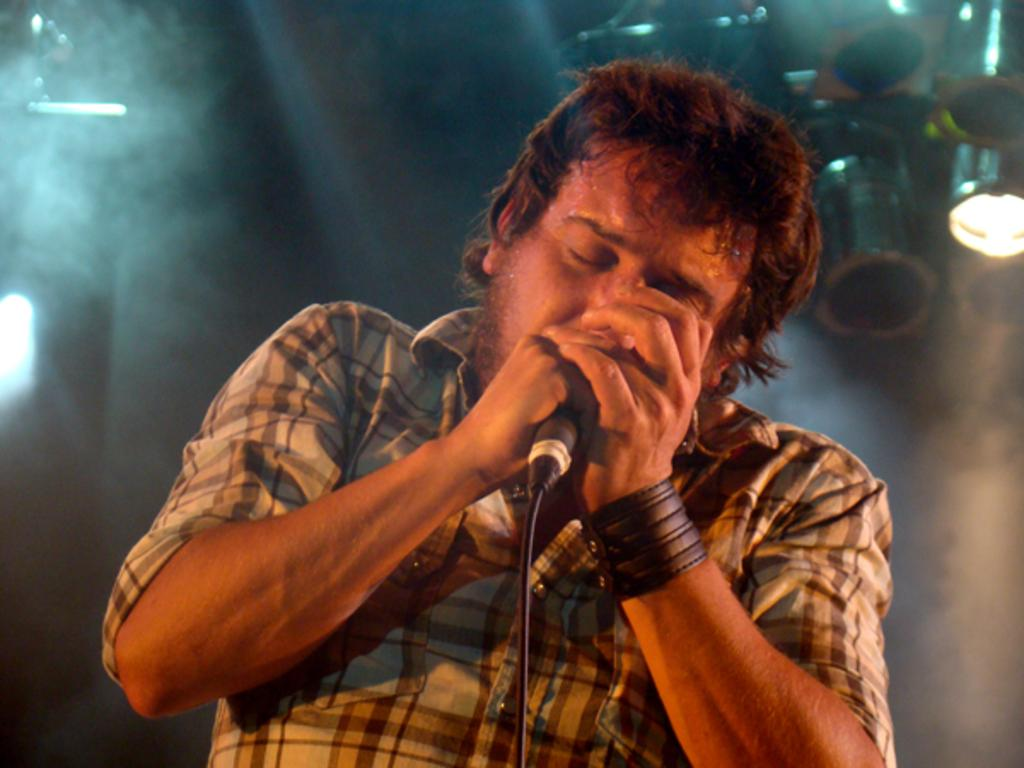What is the overall appearance of the background in the image? The background of the image is dark and smoky. What can be seen in the image besides the background? There are lights visible in the image. Can you describe the person in the image? There is a man in the image, and he is wearing a wristband. What is the man holding in his hand? The man is holding a microphone in his hand. What is the man doing in the image? The man is singing. Can you tell me how many socks the monkey is wearing in the image? There is no monkey present in the image, and therefore no socks can be observed. 